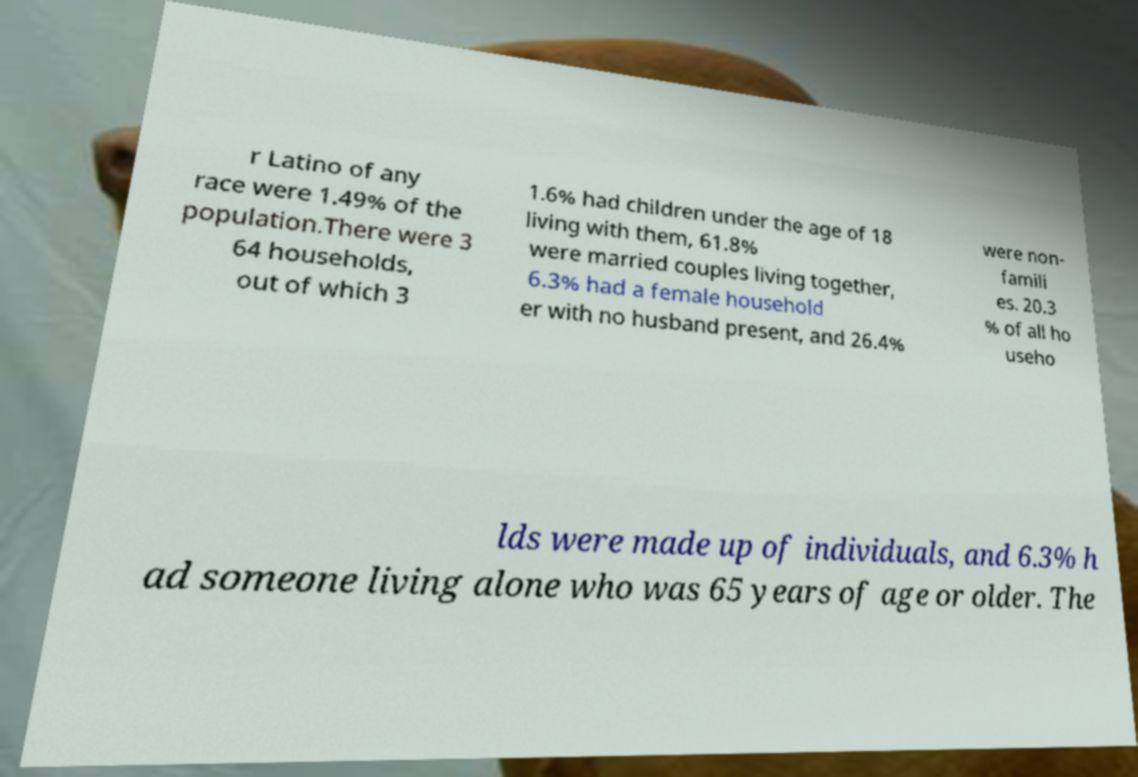Please read and relay the text visible in this image. What does it say? r Latino of any race were 1.49% of the population.There were 3 64 households, out of which 3 1.6% had children under the age of 18 living with them, 61.8% were married couples living together, 6.3% had a female household er with no husband present, and 26.4% were non- famili es. 20.3 % of all ho useho lds were made up of individuals, and 6.3% h ad someone living alone who was 65 years of age or older. The 